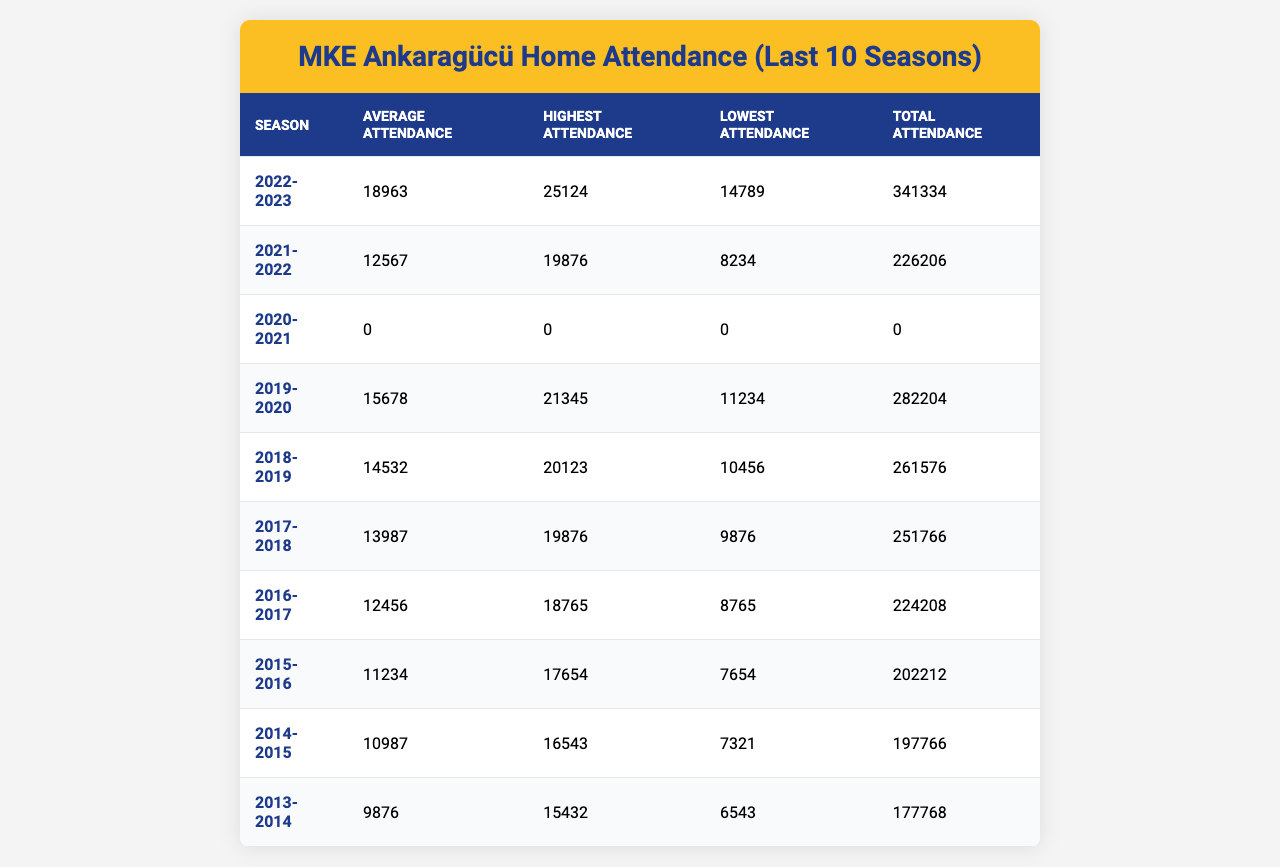What was the highest attendance figure recorded for MKE Ankaragücü in the 2022-2023 season? The table shows that the highest attendance for the 2022-2023 season is listed as 25124.
Answer: 25124 What was MKE Ankaragücü's average attendance during the 2019-2020 season? From the table, the average attendance for the 2019-2020 season is provided as 15678.
Answer: 15678 In which season did MKE Ankaragücü experience the lowest average attendance? By looking at the average attendance values, the lowest average attendance is found in the 2020-2021 season, which has an average of 0 due to no matches being held.
Answer: 2020-2021 What is the total attendance for the season 2021-2022? The total attendance for the 2021-2022 season is given as 226206 in the table.
Answer: 226206 How many more attendees did MKE Ankaragücü have in the highest attendance of the 2022-2023 season compared to the lowest attendance in the same season? The highest attendance in 2022-2023 was 25124 and the lowest was 14789. The difference is 25124 - 14789 = 10335.
Answer: 10335 Was the average attendance in the 2018-2019 season greater than that in the 2017-2018 season? The average attendance for 2018-2019 is 14532, and for 2017-2018 it is 13987. Since 14532 is greater than 13987, the answer is yes.
Answer: Yes What percentage increase in average attendance does the 2022-2023 season show compared to the 2021-2022 season? The average attendance in 2022-2023 is 18963 and in 2021-2022 is 12567. The increase is (18963 - 12567) / 12567 * 100 = 50.2%.
Answer: 50.2% If you combine the total attendance figures for the seasons 2015-2016 and 2016-2017, what will that sum be? The total attendance for 2015-2016 is 202212 and for 2016-2017 it is 224208. Adding them gives 202212 + 224208 = 426420.
Answer: 426420 What is the overall trend in attendance from the 2013-2014 season to the 2022-2023 season? By analyzing the average attendance figures from each season, we see an increase from 9876 in 2013-2014 to 18963 in 2022-2023, indicating a positive trend.
Answer: Positive trend Was there any season without recorded attendance? Yes, the 2020-2021 season shows zero attendance in all categories, indicating no matches took place, thus confirming there was a season without recorded attendance.
Answer: Yes 